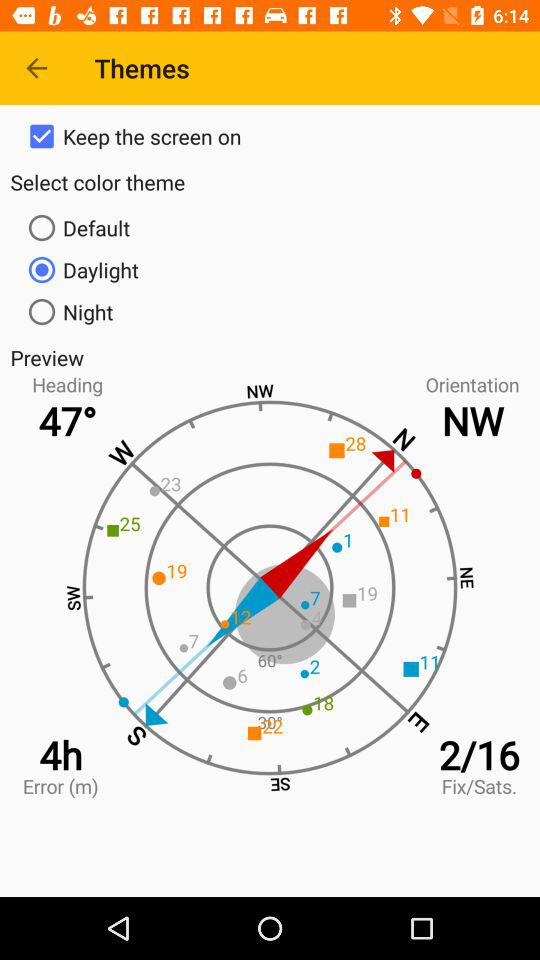What is the given "Fix/Sats."? The given "Fix/Sats." is 2/16. 